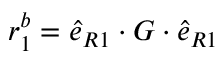Convert formula to latex. <formula><loc_0><loc_0><loc_500><loc_500>r _ { 1 } ^ { b } = \hat { e } _ { R 1 } \cdot G \cdot \hat { e } _ { R 1 }</formula> 